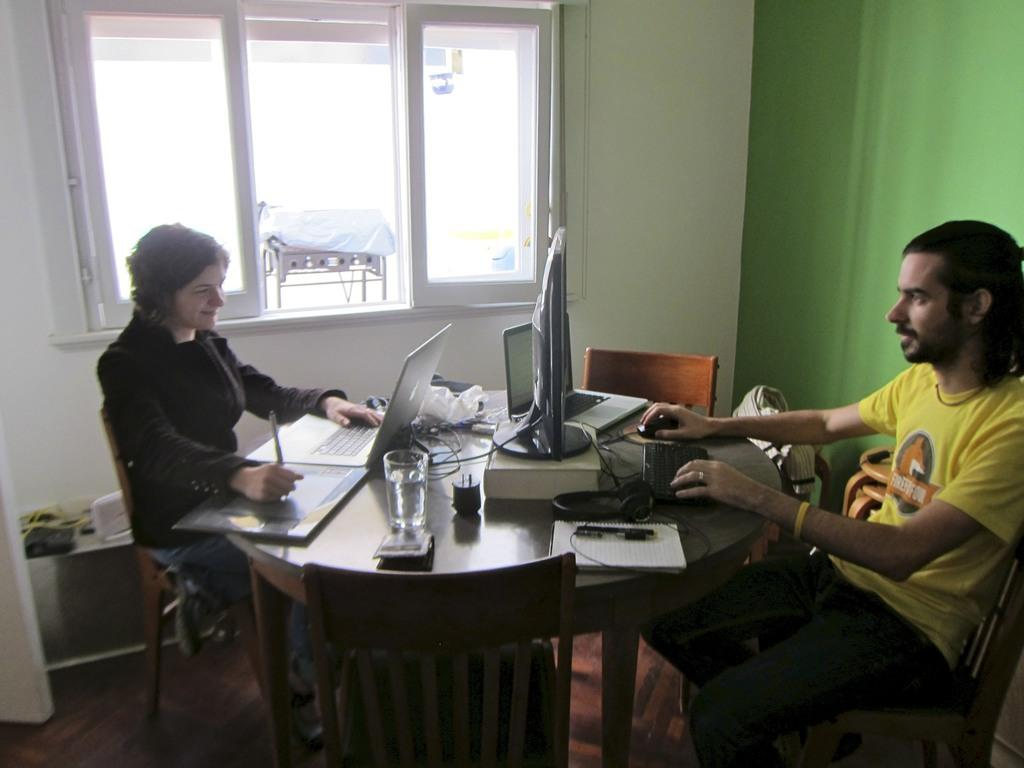How many people are in the image? There are two persons in the image. What are the persons doing in the image? The persons are sitting and looking at a computer. What objects can be seen related to the computer? There are wires, computers, pens, and paper in the image. What is on the table in the image? There is a glass on the table in the image. What can be seen at the back of the room? There is a window at the back of the room. What type of wine is being served in the image? There is no wine present in the image; it features two persons sitting and looking at a computer, along with related objects and a window at the back of the room. 